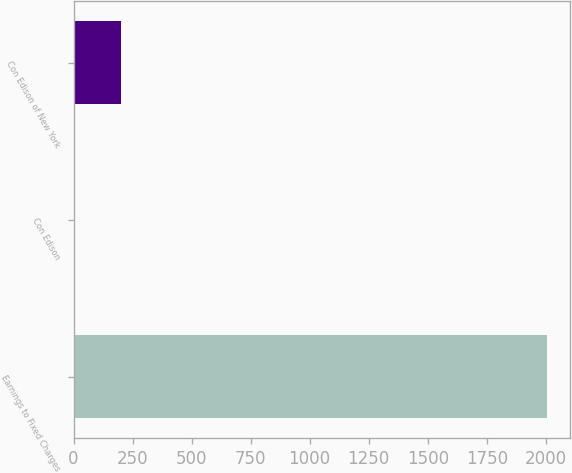Convert chart to OTSL. <chart><loc_0><loc_0><loc_500><loc_500><bar_chart><fcel>Earnings to Fixed Charges<fcel>Con Edison<fcel>Con Edison of New York<nl><fcel>2004<fcel>2.6<fcel>202.74<nl></chart> 